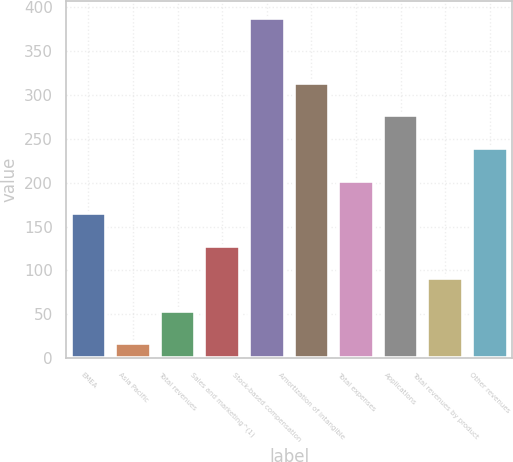Convert chart. <chart><loc_0><loc_0><loc_500><loc_500><bar_chart><fcel>EMEA<fcel>Asia Pacific<fcel>Total revenues<fcel>Sales and marketing^(1)<fcel>Stock-based compensation<fcel>Amortization of intangible<fcel>Total expenses<fcel>Applications<fcel>Total revenues by product<fcel>Other revenues<nl><fcel>165.4<fcel>17<fcel>54.1<fcel>128.3<fcel>388<fcel>313.8<fcel>202.5<fcel>276.7<fcel>91.2<fcel>239.6<nl></chart> 